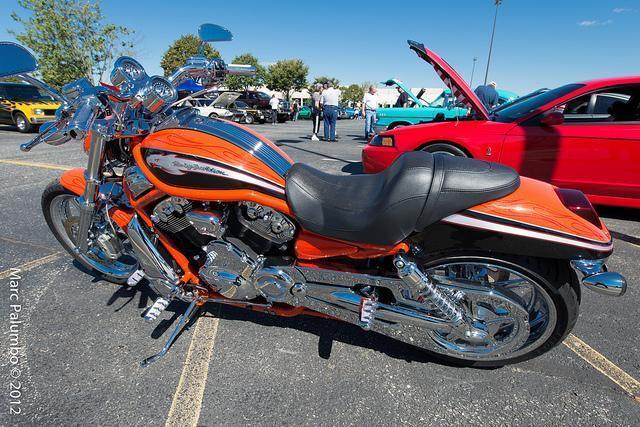How many wheels?
Give a very brief answer. 2. How many cars are there?
Give a very brief answer. 3. How many motorcycles are in the photo?
Give a very brief answer. 1. 